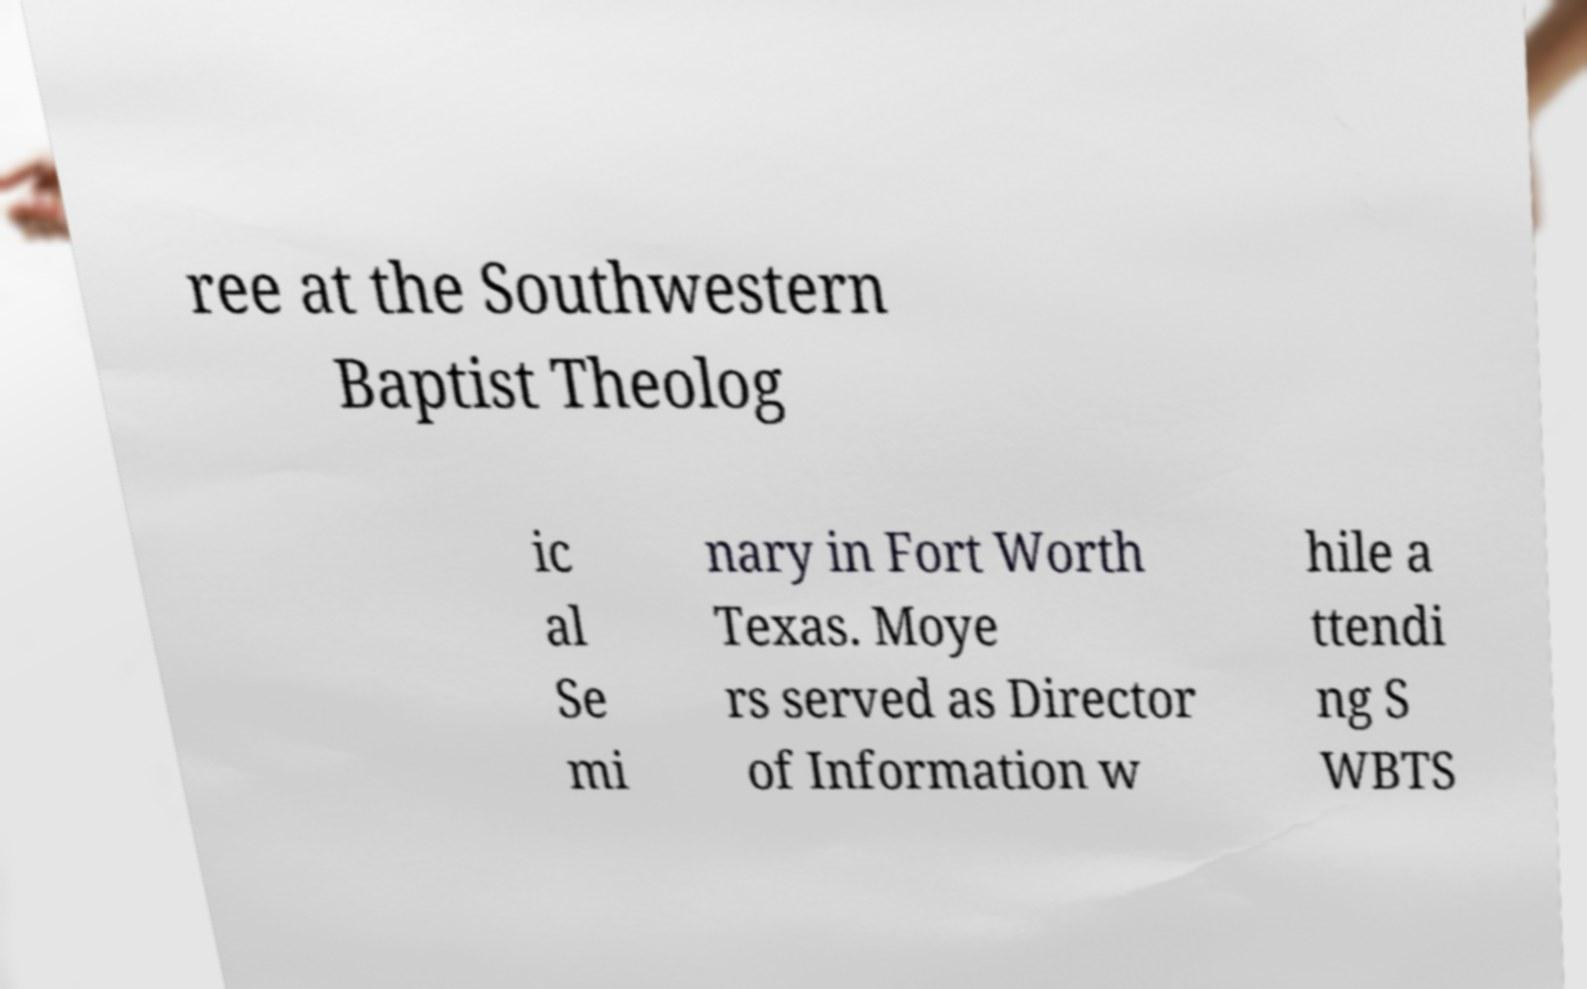Can you read and provide the text displayed in the image?This photo seems to have some interesting text. Can you extract and type it out for me? ree at the Southwestern Baptist Theolog ic al Se mi nary in Fort Worth Texas. Moye rs served as Director of Information w hile a ttendi ng S WBTS 